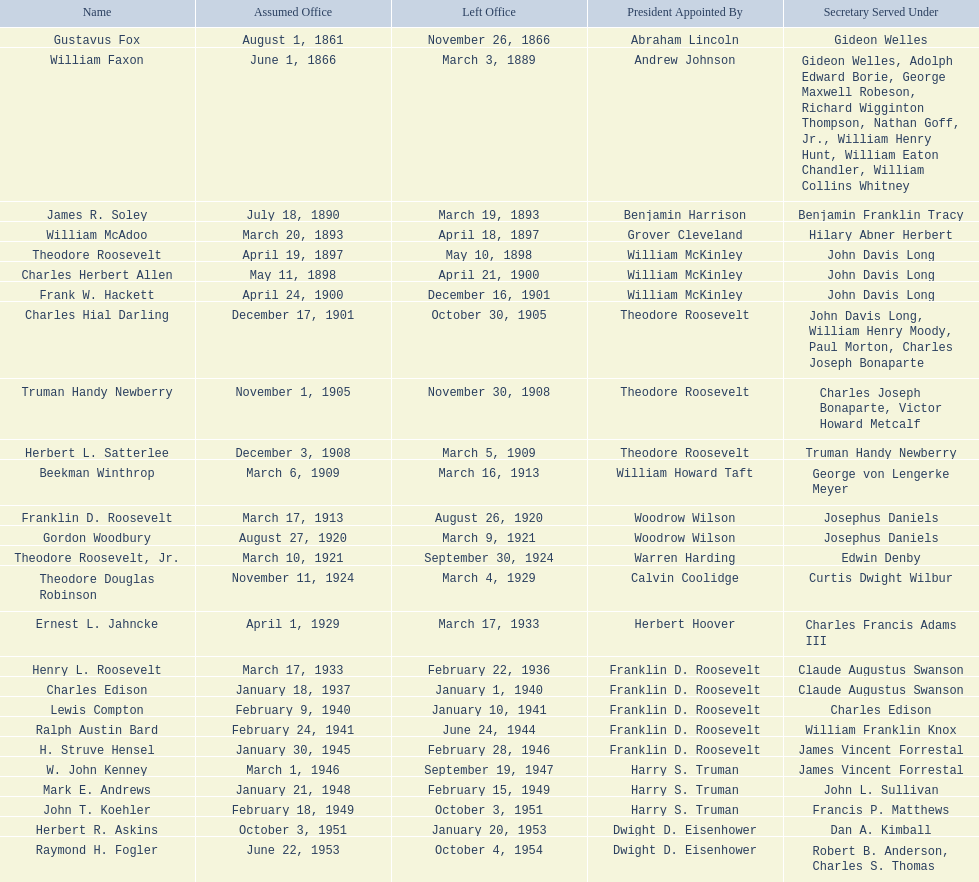Who are all the deputy secretaries of the navy in the 20th century? Charles Herbert Allen, Frank W. Hackett, Charles Hial Darling, Truman Handy Newberry, Herbert L. Satterlee, Beekman Winthrop, Franklin D. Roosevelt, Gordon Woodbury, Theodore Roosevelt, Jr., Theodore Douglas Robinson, Ernest L. Jahncke, Henry L. Roosevelt, Charles Edison, Lewis Compton, Ralph Austin Bard, H. Struve Hensel, W. John Kenney, Mark E. Andrews, John T. Koehler, Herbert R. Askins, Raymond H. Fogler. What date was deputy secretary of the navy raymond h. fogler appointed? June 22, 1953. What date did deputy secretary of the navy raymond h. fogler leave office? October 4, 1954. 